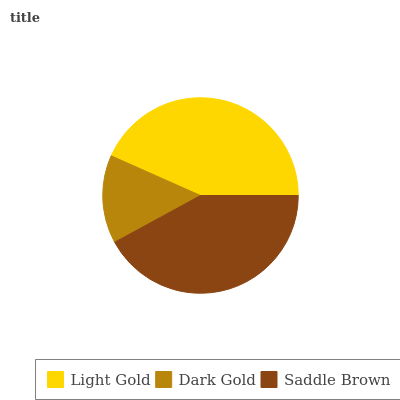Is Dark Gold the minimum?
Answer yes or no. Yes. Is Light Gold the maximum?
Answer yes or no. Yes. Is Saddle Brown the minimum?
Answer yes or no. No. Is Saddle Brown the maximum?
Answer yes or no. No. Is Saddle Brown greater than Dark Gold?
Answer yes or no. Yes. Is Dark Gold less than Saddle Brown?
Answer yes or no. Yes. Is Dark Gold greater than Saddle Brown?
Answer yes or no. No. Is Saddle Brown less than Dark Gold?
Answer yes or no. No. Is Saddle Brown the high median?
Answer yes or no. Yes. Is Saddle Brown the low median?
Answer yes or no. Yes. Is Dark Gold the high median?
Answer yes or no. No. Is Light Gold the low median?
Answer yes or no. No. 